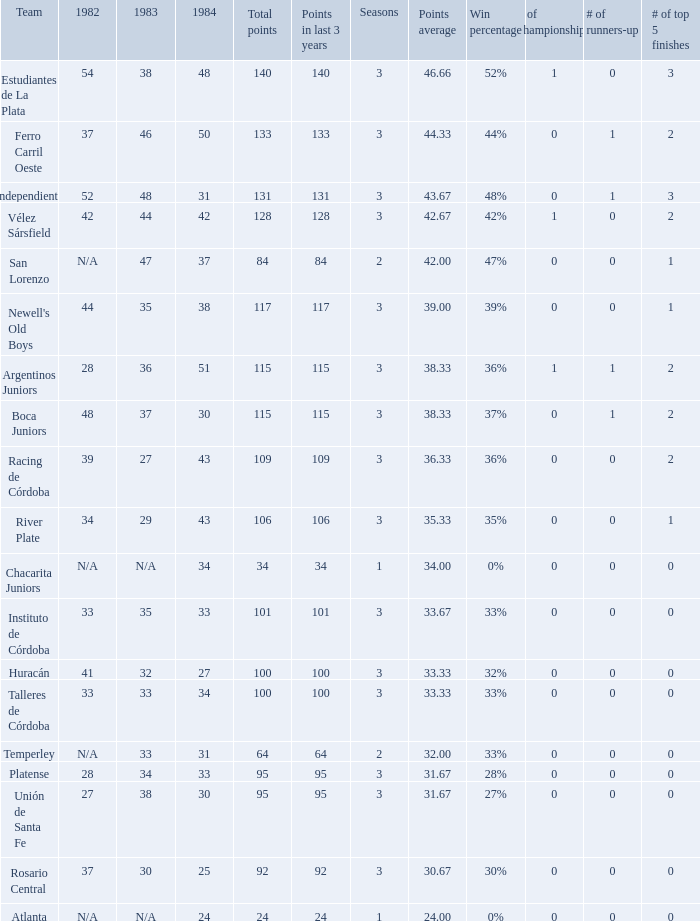What is the points total for the team with points average more than 34, 1984 score more than 37 and N/A in 1982? 0.0. 